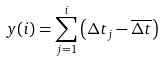<formula> <loc_0><loc_0><loc_500><loc_500>y ( i ) = \sum _ { j = 1 } ^ { i } \left ( \Delta t _ { j } - \overline { \Delta t } \right )</formula> 